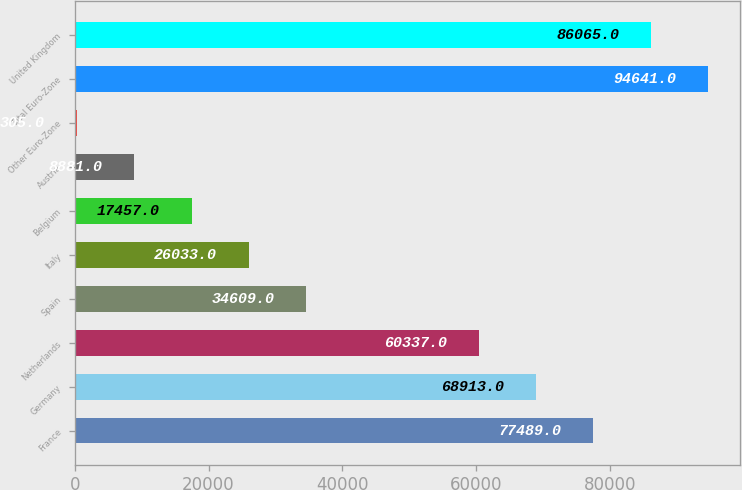<chart> <loc_0><loc_0><loc_500><loc_500><bar_chart><fcel>France<fcel>Germany<fcel>Netherlands<fcel>Spain<fcel>Italy<fcel>Belgium<fcel>Austria<fcel>Other Euro-Zone<fcel>Total Euro-Zone<fcel>United Kingdom<nl><fcel>77489<fcel>68913<fcel>60337<fcel>34609<fcel>26033<fcel>17457<fcel>8881<fcel>305<fcel>94641<fcel>86065<nl></chart> 